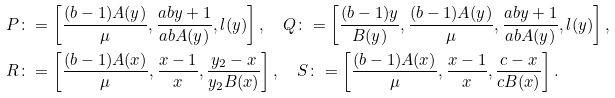Convert formula to latex. <formula><loc_0><loc_0><loc_500><loc_500>P & \colon = \left [ \frac { ( b - 1 ) A ( y ) } { \mu } , \frac { a b y + 1 } { a b A ( y ) } , l ( y ) \right ] , \quad Q \colon = \left [ \frac { ( b - 1 ) y } { B ( y ) } , \frac { ( b - 1 ) A ( y ) } { \mu } , \frac { a b y + 1 } { a b A ( y ) } , l ( y ) \right ] , \\ R & \colon = \left [ \frac { ( b - 1 ) A ( x ) } { \mu } , \frac { x - 1 } { x } , \frac { y _ { 2 } - x } { y _ { 2 } B ( x ) } \right ] , \quad S \colon = \left [ \frac { ( b - 1 ) A ( x ) } { \mu } , \frac { x - 1 } { x } , \frac { c - x } { c B ( x ) } \right ] . \\</formula> 